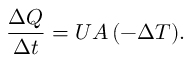<formula> <loc_0><loc_0><loc_500><loc_500>{ \Big . } { \frac { \Delta Q } { \Delta t } } = U A \, ( - \Delta T ) .</formula> 